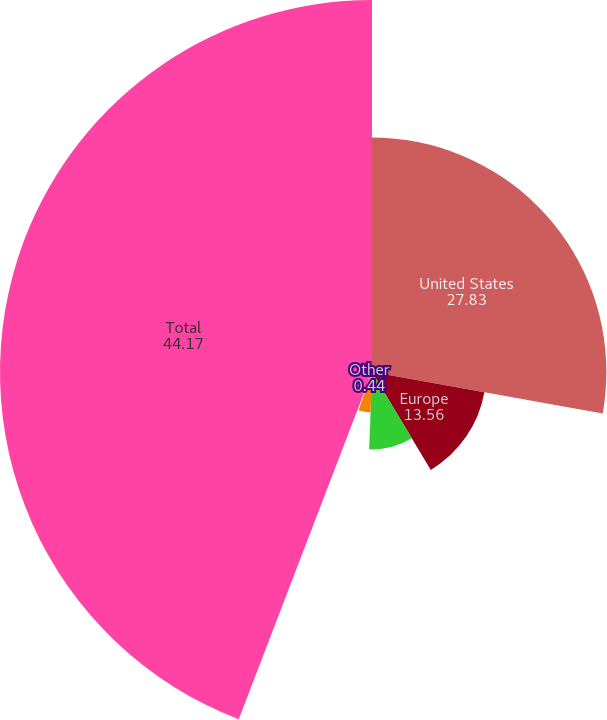Convert chart. <chart><loc_0><loc_0><loc_500><loc_500><pie_chart><fcel>United States<fcel>Europe<fcel>Latin America the Middle East<fcel>Emerging Markets<fcel>Other<fcel>Total<nl><fcel>27.83%<fcel>13.56%<fcel>9.19%<fcel>4.81%<fcel>0.44%<fcel>44.17%<nl></chart> 